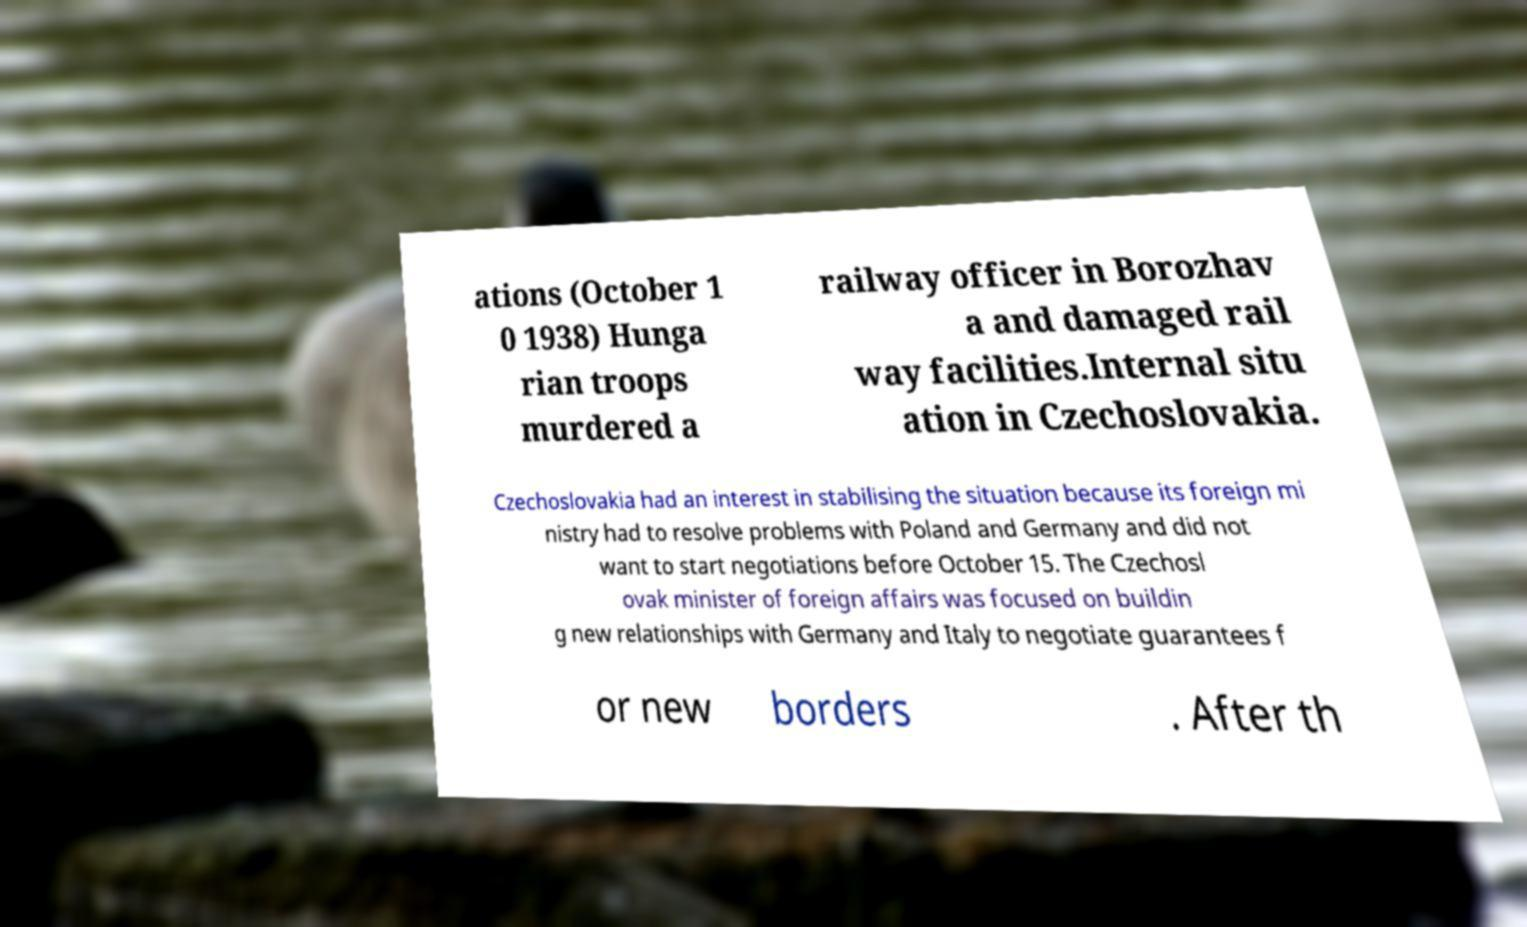Please identify and transcribe the text found in this image. ations (October 1 0 1938) Hunga rian troops murdered a railway officer in Borozhav a and damaged rail way facilities.Internal situ ation in Czechoslovakia. Czechoslovakia had an interest in stabilising the situation because its foreign mi nistry had to resolve problems with Poland and Germany and did not want to start negotiations before October 15. The Czechosl ovak minister of foreign affairs was focused on buildin g new relationships with Germany and Italy to negotiate guarantees f or new borders . After th 